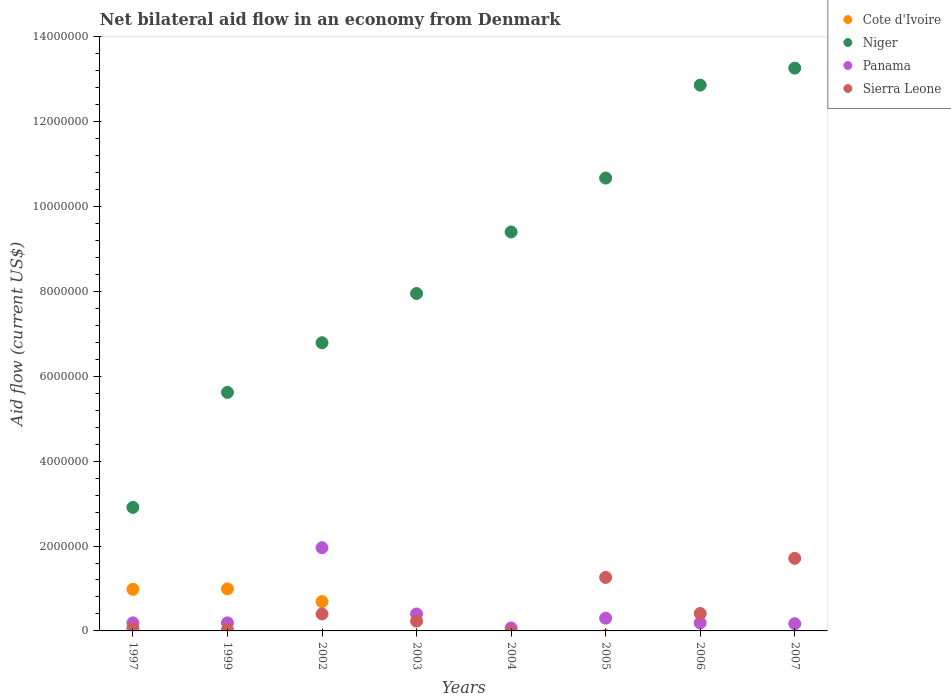How many different coloured dotlines are there?
Your response must be concise. 4. Is the number of dotlines equal to the number of legend labels?
Ensure brevity in your answer.  No. Across all years, what is the maximum net bilateral aid flow in Niger?
Your answer should be very brief. 1.33e+07. Across all years, what is the minimum net bilateral aid flow in Niger?
Provide a short and direct response. 2.91e+06. In which year was the net bilateral aid flow in Cote d'Ivoire maximum?
Give a very brief answer. 1999. What is the total net bilateral aid flow in Sierra Leone in the graph?
Provide a short and direct response. 4.10e+06. What is the difference between the net bilateral aid flow in Niger in 2004 and that in 2005?
Ensure brevity in your answer.  -1.27e+06. What is the difference between the net bilateral aid flow in Sierra Leone in 1999 and the net bilateral aid flow in Cote d'Ivoire in 2005?
Provide a succinct answer. 3.00e+04. What is the average net bilateral aid flow in Panama per year?
Your answer should be very brief. 4.34e+05. In the year 2006, what is the difference between the net bilateral aid flow in Panama and net bilateral aid flow in Niger?
Your answer should be compact. -1.27e+07. In how many years, is the net bilateral aid flow in Sierra Leone greater than 6800000 US$?
Keep it short and to the point. 0. Is the difference between the net bilateral aid flow in Panama in 1999 and 2005 greater than the difference between the net bilateral aid flow in Niger in 1999 and 2005?
Make the answer very short. Yes. What is the difference between the highest and the second highest net bilateral aid flow in Niger?
Offer a very short reply. 4.00e+05. What is the difference between the highest and the lowest net bilateral aid flow in Cote d'Ivoire?
Provide a short and direct response. 9.90e+05. Is it the case that in every year, the sum of the net bilateral aid flow in Cote d'Ivoire and net bilateral aid flow in Panama  is greater than the sum of net bilateral aid flow in Niger and net bilateral aid flow in Sierra Leone?
Your answer should be very brief. No. Is it the case that in every year, the sum of the net bilateral aid flow in Sierra Leone and net bilateral aid flow in Cote d'Ivoire  is greater than the net bilateral aid flow in Niger?
Keep it short and to the point. No. Are the values on the major ticks of Y-axis written in scientific E-notation?
Keep it short and to the point. No. Where does the legend appear in the graph?
Your answer should be very brief. Top right. What is the title of the graph?
Make the answer very short. Net bilateral aid flow in an economy from Denmark. Does "Serbia" appear as one of the legend labels in the graph?
Keep it short and to the point. No. What is the label or title of the X-axis?
Provide a succinct answer. Years. What is the label or title of the Y-axis?
Offer a terse response. Aid flow (current US$). What is the Aid flow (current US$) in Cote d'Ivoire in 1997?
Make the answer very short. 9.80e+05. What is the Aid flow (current US$) in Niger in 1997?
Ensure brevity in your answer.  2.91e+06. What is the Aid flow (current US$) in Panama in 1997?
Offer a terse response. 1.90e+05. What is the Aid flow (current US$) of Sierra Leone in 1997?
Keep it short and to the point. 6.00e+04. What is the Aid flow (current US$) in Cote d'Ivoire in 1999?
Offer a very short reply. 9.90e+05. What is the Aid flow (current US$) of Niger in 1999?
Offer a very short reply. 5.62e+06. What is the Aid flow (current US$) of Cote d'Ivoire in 2002?
Provide a short and direct response. 6.90e+05. What is the Aid flow (current US$) in Niger in 2002?
Offer a terse response. 6.79e+06. What is the Aid flow (current US$) of Panama in 2002?
Provide a succinct answer. 1.96e+06. What is the Aid flow (current US$) in Niger in 2003?
Give a very brief answer. 7.95e+06. What is the Aid flow (current US$) in Cote d'Ivoire in 2004?
Your response must be concise. 0. What is the Aid flow (current US$) in Niger in 2004?
Your answer should be very brief. 9.40e+06. What is the Aid flow (current US$) of Panama in 2004?
Your response must be concise. 7.00e+04. What is the Aid flow (current US$) in Cote d'Ivoire in 2005?
Ensure brevity in your answer.  0. What is the Aid flow (current US$) of Niger in 2005?
Your answer should be compact. 1.07e+07. What is the Aid flow (current US$) of Sierra Leone in 2005?
Provide a succinct answer. 1.26e+06. What is the Aid flow (current US$) in Niger in 2006?
Offer a very short reply. 1.29e+07. What is the Aid flow (current US$) of Panama in 2006?
Provide a short and direct response. 1.90e+05. What is the Aid flow (current US$) in Sierra Leone in 2006?
Your answer should be compact. 4.10e+05. What is the Aid flow (current US$) in Cote d'Ivoire in 2007?
Give a very brief answer. 0. What is the Aid flow (current US$) of Niger in 2007?
Provide a short and direct response. 1.33e+07. What is the Aid flow (current US$) in Panama in 2007?
Provide a succinct answer. 1.70e+05. What is the Aid flow (current US$) of Sierra Leone in 2007?
Give a very brief answer. 1.71e+06. Across all years, what is the maximum Aid flow (current US$) of Cote d'Ivoire?
Provide a short and direct response. 9.90e+05. Across all years, what is the maximum Aid flow (current US$) in Niger?
Your answer should be very brief. 1.33e+07. Across all years, what is the maximum Aid flow (current US$) of Panama?
Your response must be concise. 1.96e+06. Across all years, what is the maximum Aid flow (current US$) of Sierra Leone?
Your answer should be compact. 1.71e+06. Across all years, what is the minimum Aid flow (current US$) in Cote d'Ivoire?
Ensure brevity in your answer.  0. Across all years, what is the minimum Aid flow (current US$) of Niger?
Offer a very short reply. 2.91e+06. Across all years, what is the minimum Aid flow (current US$) of Panama?
Your response must be concise. 7.00e+04. What is the total Aid flow (current US$) of Cote d'Ivoire in the graph?
Your response must be concise. 2.66e+06. What is the total Aid flow (current US$) in Niger in the graph?
Make the answer very short. 6.95e+07. What is the total Aid flow (current US$) of Panama in the graph?
Your answer should be very brief. 3.47e+06. What is the total Aid flow (current US$) in Sierra Leone in the graph?
Keep it short and to the point. 4.10e+06. What is the difference between the Aid flow (current US$) in Cote d'Ivoire in 1997 and that in 1999?
Offer a terse response. -10000. What is the difference between the Aid flow (current US$) in Niger in 1997 and that in 1999?
Ensure brevity in your answer.  -2.71e+06. What is the difference between the Aid flow (current US$) of Panama in 1997 and that in 1999?
Your answer should be compact. 0. What is the difference between the Aid flow (current US$) of Cote d'Ivoire in 1997 and that in 2002?
Make the answer very short. 2.90e+05. What is the difference between the Aid flow (current US$) in Niger in 1997 and that in 2002?
Your response must be concise. -3.88e+06. What is the difference between the Aid flow (current US$) in Panama in 1997 and that in 2002?
Provide a succinct answer. -1.77e+06. What is the difference between the Aid flow (current US$) in Sierra Leone in 1997 and that in 2002?
Your answer should be compact. -3.40e+05. What is the difference between the Aid flow (current US$) in Niger in 1997 and that in 2003?
Your answer should be compact. -5.04e+06. What is the difference between the Aid flow (current US$) in Panama in 1997 and that in 2003?
Offer a terse response. -2.10e+05. What is the difference between the Aid flow (current US$) of Niger in 1997 and that in 2004?
Keep it short and to the point. -6.49e+06. What is the difference between the Aid flow (current US$) in Panama in 1997 and that in 2004?
Your answer should be very brief. 1.20e+05. What is the difference between the Aid flow (current US$) of Niger in 1997 and that in 2005?
Offer a very short reply. -7.76e+06. What is the difference between the Aid flow (current US$) of Panama in 1997 and that in 2005?
Keep it short and to the point. -1.10e+05. What is the difference between the Aid flow (current US$) in Sierra Leone in 1997 and that in 2005?
Your answer should be compact. -1.20e+06. What is the difference between the Aid flow (current US$) in Niger in 1997 and that in 2006?
Keep it short and to the point. -9.95e+06. What is the difference between the Aid flow (current US$) of Sierra Leone in 1997 and that in 2006?
Offer a terse response. -3.50e+05. What is the difference between the Aid flow (current US$) in Niger in 1997 and that in 2007?
Keep it short and to the point. -1.04e+07. What is the difference between the Aid flow (current US$) in Panama in 1997 and that in 2007?
Provide a short and direct response. 2.00e+04. What is the difference between the Aid flow (current US$) of Sierra Leone in 1997 and that in 2007?
Your answer should be compact. -1.65e+06. What is the difference between the Aid flow (current US$) in Cote d'Ivoire in 1999 and that in 2002?
Your response must be concise. 3.00e+05. What is the difference between the Aid flow (current US$) in Niger in 1999 and that in 2002?
Give a very brief answer. -1.17e+06. What is the difference between the Aid flow (current US$) in Panama in 1999 and that in 2002?
Your answer should be very brief. -1.77e+06. What is the difference between the Aid flow (current US$) in Sierra Leone in 1999 and that in 2002?
Your answer should be very brief. -3.70e+05. What is the difference between the Aid flow (current US$) of Niger in 1999 and that in 2003?
Offer a very short reply. -2.33e+06. What is the difference between the Aid flow (current US$) in Sierra Leone in 1999 and that in 2003?
Your response must be concise. -2.00e+05. What is the difference between the Aid flow (current US$) of Niger in 1999 and that in 2004?
Your answer should be very brief. -3.78e+06. What is the difference between the Aid flow (current US$) of Niger in 1999 and that in 2005?
Your response must be concise. -5.05e+06. What is the difference between the Aid flow (current US$) of Panama in 1999 and that in 2005?
Make the answer very short. -1.10e+05. What is the difference between the Aid flow (current US$) in Sierra Leone in 1999 and that in 2005?
Offer a terse response. -1.23e+06. What is the difference between the Aid flow (current US$) of Niger in 1999 and that in 2006?
Make the answer very short. -7.24e+06. What is the difference between the Aid flow (current US$) of Panama in 1999 and that in 2006?
Provide a short and direct response. 0. What is the difference between the Aid flow (current US$) of Sierra Leone in 1999 and that in 2006?
Your answer should be compact. -3.80e+05. What is the difference between the Aid flow (current US$) in Niger in 1999 and that in 2007?
Give a very brief answer. -7.64e+06. What is the difference between the Aid flow (current US$) of Panama in 1999 and that in 2007?
Your answer should be compact. 2.00e+04. What is the difference between the Aid flow (current US$) of Sierra Leone in 1999 and that in 2007?
Your response must be concise. -1.68e+06. What is the difference between the Aid flow (current US$) in Niger in 2002 and that in 2003?
Provide a succinct answer. -1.16e+06. What is the difference between the Aid flow (current US$) of Panama in 2002 and that in 2003?
Keep it short and to the point. 1.56e+06. What is the difference between the Aid flow (current US$) in Sierra Leone in 2002 and that in 2003?
Make the answer very short. 1.70e+05. What is the difference between the Aid flow (current US$) of Niger in 2002 and that in 2004?
Offer a very short reply. -2.61e+06. What is the difference between the Aid flow (current US$) in Panama in 2002 and that in 2004?
Your answer should be compact. 1.89e+06. What is the difference between the Aid flow (current US$) in Niger in 2002 and that in 2005?
Offer a terse response. -3.88e+06. What is the difference between the Aid flow (current US$) of Panama in 2002 and that in 2005?
Offer a terse response. 1.66e+06. What is the difference between the Aid flow (current US$) of Sierra Leone in 2002 and that in 2005?
Your answer should be compact. -8.60e+05. What is the difference between the Aid flow (current US$) in Niger in 2002 and that in 2006?
Offer a terse response. -6.07e+06. What is the difference between the Aid flow (current US$) of Panama in 2002 and that in 2006?
Your response must be concise. 1.77e+06. What is the difference between the Aid flow (current US$) of Niger in 2002 and that in 2007?
Provide a succinct answer. -6.47e+06. What is the difference between the Aid flow (current US$) in Panama in 2002 and that in 2007?
Keep it short and to the point. 1.79e+06. What is the difference between the Aid flow (current US$) in Sierra Leone in 2002 and that in 2007?
Make the answer very short. -1.31e+06. What is the difference between the Aid flow (current US$) of Niger in 2003 and that in 2004?
Provide a succinct answer. -1.45e+06. What is the difference between the Aid flow (current US$) in Panama in 2003 and that in 2004?
Your answer should be compact. 3.30e+05. What is the difference between the Aid flow (current US$) in Niger in 2003 and that in 2005?
Give a very brief answer. -2.72e+06. What is the difference between the Aid flow (current US$) in Panama in 2003 and that in 2005?
Your answer should be compact. 1.00e+05. What is the difference between the Aid flow (current US$) in Sierra Leone in 2003 and that in 2005?
Your answer should be very brief. -1.03e+06. What is the difference between the Aid flow (current US$) in Niger in 2003 and that in 2006?
Your response must be concise. -4.91e+06. What is the difference between the Aid flow (current US$) in Niger in 2003 and that in 2007?
Your answer should be compact. -5.31e+06. What is the difference between the Aid flow (current US$) in Sierra Leone in 2003 and that in 2007?
Your answer should be very brief. -1.48e+06. What is the difference between the Aid flow (current US$) in Niger in 2004 and that in 2005?
Keep it short and to the point. -1.27e+06. What is the difference between the Aid flow (current US$) in Niger in 2004 and that in 2006?
Ensure brevity in your answer.  -3.46e+06. What is the difference between the Aid flow (current US$) of Panama in 2004 and that in 2006?
Your answer should be compact. -1.20e+05. What is the difference between the Aid flow (current US$) in Niger in 2004 and that in 2007?
Your answer should be very brief. -3.86e+06. What is the difference between the Aid flow (current US$) in Niger in 2005 and that in 2006?
Your answer should be compact. -2.19e+06. What is the difference between the Aid flow (current US$) of Panama in 2005 and that in 2006?
Your response must be concise. 1.10e+05. What is the difference between the Aid flow (current US$) in Sierra Leone in 2005 and that in 2006?
Make the answer very short. 8.50e+05. What is the difference between the Aid flow (current US$) of Niger in 2005 and that in 2007?
Ensure brevity in your answer.  -2.59e+06. What is the difference between the Aid flow (current US$) of Panama in 2005 and that in 2007?
Offer a terse response. 1.30e+05. What is the difference between the Aid flow (current US$) of Sierra Leone in 2005 and that in 2007?
Your response must be concise. -4.50e+05. What is the difference between the Aid flow (current US$) in Niger in 2006 and that in 2007?
Your answer should be very brief. -4.00e+05. What is the difference between the Aid flow (current US$) in Sierra Leone in 2006 and that in 2007?
Make the answer very short. -1.30e+06. What is the difference between the Aid flow (current US$) of Cote d'Ivoire in 1997 and the Aid flow (current US$) of Niger in 1999?
Your response must be concise. -4.64e+06. What is the difference between the Aid flow (current US$) of Cote d'Ivoire in 1997 and the Aid flow (current US$) of Panama in 1999?
Offer a terse response. 7.90e+05. What is the difference between the Aid flow (current US$) in Cote d'Ivoire in 1997 and the Aid flow (current US$) in Sierra Leone in 1999?
Offer a very short reply. 9.50e+05. What is the difference between the Aid flow (current US$) of Niger in 1997 and the Aid flow (current US$) of Panama in 1999?
Your answer should be compact. 2.72e+06. What is the difference between the Aid flow (current US$) of Niger in 1997 and the Aid flow (current US$) of Sierra Leone in 1999?
Ensure brevity in your answer.  2.88e+06. What is the difference between the Aid flow (current US$) of Panama in 1997 and the Aid flow (current US$) of Sierra Leone in 1999?
Make the answer very short. 1.60e+05. What is the difference between the Aid flow (current US$) in Cote d'Ivoire in 1997 and the Aid flow (current US$) in Niger in 2002?
Your answer should be compact. -5.81e+06. What is the difference between the Aid flow (current US$) in Cote d'Ivoire in 1997 and the Aid flow (current US$) in Panama in 2002?
Ensure brevity in your answer.  -9.80e+05. What is the difference between the Aid flow (current US$) in Cote d'Ivoire in 1997 and the Aid flow (current US$) in Sierra Leone in 2002?
Offer a terse response. 5.80e+05. What is the difference between the Aid flow (current US$) of Niger in 1997 and the Aid flow (current US$) of Panama in 2002?
Offer a terse response. 9.50e+05. What is the difference between the Aid flow (current US$) in Niger in 1997 and the Aid flow (current US$) in Sierra Leone in 2002?
Your answer should be very brief. 2.51e+06. What is the difference between the Aid flow (current US$) in Cote d'Ivoire in 1997 and the Aid flow (current US$) in Niger in 2003?
Give a very brief answer. -6.97e+06. What is the difference between the Aid flow (current US$) in Cote d'Ivoire in 1997 and the Aid flow (current US$) in Panama in 2003?
Offer a terse response. 5.80e+05. What is the difference between the Aid flow (current US$) of Cote d'Ivoire in 1997 and the Aid flow (current US$) of Sierra Leone in 2003?
Ensure brevity in your answer.  7.50e+05. What is the difference between the Aid flow (current US$) in Niger in 1997 and the Aid flow (current US$) in Panama in 2003?
Your response must be concise. 2.51e+06. What is the difference between the Aid flow (current US$) in Niger in 1997 and the Aid flow (current US$) in Sierra Leone in 2003?
Provide a succinct answer. 2.68e+06. What is the difference between the Aid flow (current US$) of Panama in 1997 and the Aid flow (current US$) of Sierra Leone in 2003?
Give a very brief answer. -4.00e+04. What is the difference between the Aid flow (current US$) in Cote d'Ivoire in 1997 and the Aid flow (current US$) in Niger in 2004?
Offer a very short reply. -8.42e+06. What is the difference between the Aid flow (current US$) of Cote d'Ivoire in 1997 and the Aid flow (current US$) of Panama in 2004?
Ensure brevity in your answer.  9.10e+05. What is the difference between the Aid flow (current US$) of Niger in 1997 and the Aid flow (current US$) of Panama in 2004?
Offer a terse response. 2.84e+06. What is the difference between the Aid flow (current US$) of Cote d'Ivoire in 1997 and the Aid flow (current US$) of Niger in 2005?
Offer a terse response. -9.69e+06. What is the difference between the Aid flow (current US$) of Cote d'Ivoire in 1997 and the Aid flow (current US$) of Panama in 2005?
Keep it short and to the point. 6.80e+05. What is the difference between the Aid flow (current US$) in Cote d'Ivoire in 1997 and the Aid flow (current US$) in Sierra Leone in 2005?
Offer a very short reply. -2.80e+05. What is the difference between the Aid flow (current US$) in Niger in 1997 and the Aid flow (current US$) in Panama in 2005?
Your answer should be compact. 2.61e+06. What is the difference between the Aid flow (current US$) of Niger in 1997 and the Aid flow (current US$) of Sierra Leone in 2005?
Your answer should be very brief. 1.65e+06. What is the difference between the Aid flow (current US$) of Panama in 1997 and the Aid flow (current US$) of Sierra Leone in 2005?
Ensure brevity in your answer.  -1.07e+06. What is the difference between the Aid flow (current US$) in Cote d'Ivoire in 1997 and the Aid flow (current US$) in Niger in 2006?
Provide a short and direct response. -1.19e+07. What is the difference between the Aid flow (current US$) of Cote d'Ivoire in 1997 and the Aid flow (current US$) of Panama in 2006?
Make the answer very short. 7.90e+05. What is the difference between the Aid flow (current US$) of Cote d'Ivoire in 1997 and the Aid flow (current US$) of Sierra Leone in 2006?
Give a very brief answer. 5.70e+05. What is the difference between the Aid flow (current US$) in Niger in 1997 and the Aid flow (current US$) in Panama in 2006?
Make the answer very short. 2.72e+06. What is the difference between the Aid flow (current US$) in Niger in 1997 and the Aid flow (current US$) in Sierra Leone in 2006?
Offer a terse response. 2.50e+06. What is the difference between the Aid flow (current US$) of Panama in 1997 and the Aid flow (current US$) of Sierra Leone in 2006?
Offer a terse response. -2.20e+05. What is the difference between the Aid flow (current US$) in Cote d'Ivoire in 1997 and the Aid flow (current US$) in Niger in 2007?
Keep it short and to the point. -1.23e+07. What is the difference between the Aid flow (current US$) in Cote d'Ivoire in 1997 and the Aid flow (current US$) in Panama in 2007?
Your response must be concise. 8.10e+05. What is the difference between the Aid flow (current US$) in Cote d'Ivoire in 1997 and the Aid flow (current US$) in Sierra Leone in 2007?
Make the answer very short. -7.30e+05. What is the difference between the Aid flow (current US$) of Niger in 1997 and the Aid flow (current US$) of Panama in 2007?
Your answer should be very brief. 2.74e+06. What is the difference between the Aid flow (current US$) in Niger in 1997 and the Aid flow (current US$) in Sierra Leone in 2007?
Your answer should be compact. 1.20e+06. What is the difference between the Aid flow (current US$) in Panama in 1997 and the Aid flow (current US$) in Sierra Leone in 2007?
Your answer should be compact. -1.52e+06. What is the difference between the Aid flow (current US$) of Cote d'Ivoire in 1999 and the Aid flow (current US$) of Niger in 2002?
Keep it short and to the point. -5.80e+06. What is the difference between the Aid flow (current US$) of Cote d'Ivoire in 1999 and the Aid flow (current US$) of Panama in 2002?
Keep it short and to the point. -9.70e+05. What is the difference between the Aid flow (current US$) of Cote d'Ivoire in 1999 and the Aid flow (current US$) of Sierra Leone in 2002?
Give a very brief answer. 5.90e+05. What is the difference between the Aid flow (current US$) in Niger in 1999 and the Aid flow (current US$) in Panama in 2002?
Make the answer very short. 3.66e+06. What is the difference between the Aid flow (current US$) of Niger in 1999 and the Aid flow (current US$) of Sierra Leone in 2002?
Your answer should be very brief. 5.22e+06. What is the difference between the Aid flow (current US$) in Panama in 1999 and the Aid flow (current US$) in Sierra Leone in 2002?
Your answer should be compact. -2.10e+05. What is the difference between the Aid flow (current US$) of Cote d'Ivoire in 1999 and the Aid flow (current US$) of Niger in 2003?
Your response must be concise. -6.96e+06. What is the difference between the Aid flow (current US$) of Cote d'Ivoire in 1999 and the Aid flow (current US$) of Panama in 2003?
Keep it short and to the point. 5.90e+05. What is the difference between the Aid flow (current US$) in Cote d'Ivoire in 1999 and the Aid flow (current US$) in Sierra Leone in 2003?
Your answer should be very brief. 7.60e+05. What is the difference between the Aid flow (current US$) of Niger in 1999 and the Aid flow (current US$) of Panama in 2003?
Ensure brevity in your answer.  5.22e+06. What is the difference between the Aid flow (current US$) in Niger in 1999 and the Aid flow (current US$) in Sierra Leone in 2003?
Provide a succinct answer. 5.39e+06. What is the difference between the Aid flow (current US$) of Cote d'Ivoire in 1999 and the Aid flow (current US$) of Niger in 2004?
Offer a terse response. -8.41e+06. What is the difference between the Aid flow (current US$) of Cote d'Ivoire in 1999 and the Aid flow (current US$) of Panama in 2004?
Ensure brevity in your answer.  9.20e+05. What is the difference between the Aid flow (current US$) of Niger in 1999 and the Aid flow (current US$) of Panama in 2004?
Your answer should be compact. 5.55e+06. What is the difference between the Aid flow (current US$) in Cote d'Ivoire in 1999 and the Aid flow (current US$) in Niger in 2005?
Provide a succinct answer. -9.68e+06. What is the difference between the Aid flow (current US$) in Cote d'Ivoire in 1999 and the Aid flow (current US$) in Panama in 2005?
Your answer should be very brief. 6.90e+05. What is the difference between the Aid flow (current US$) of Niger in 1999 and the Aid flow (current US$) of Panama in 2005?
Offer a terse response. 5.32e+06. What is the difference between the Aid flow (current US$) of Niger in 1999 and the Aid flow (current US$) of Sierra Leone in 2005?
Give a very brief answer. 4.36e+06. What is the difference between the Aid flow (current US$) in Panama in 1999 and the Aid flow (current US$) in Sierra Leone in 2005?
Give a very brief answer. -1.07e+06. What is the difference between the Aid flow (current US$) in Cote d'Ivoire in 1999 and the Aid flow (current US$) in Niger in 2006?
Provide a succinct answer. -1.19e+07. What is the difference between the Aid flow (current US$) of Cote d'Ivoire in 1999 and the Aid flow (current US$) of Sierra Leone in 2006?
Provide a succinct answer. 5.80e+05. What is the difference between the Aid flow (current US$) of Niger in 1999 and the Aid flow (current US$) of Panama in 2006?
Your response must be concise. 5.43e+06. What is the difference between the Aid flow (current US$) in Niger in 1999 and the Aid flow (current US$) in Sierra Leone in 2006?
Provide a short and direct response. 5.21e+06. What is the difference between the Aid flow (current US$) of Panama in 1999 and the Aid flow (current US$) of Sierra Leone in 2006?
Your answer should be very brief. -2.20e+05. What is the difference between the Aid flow (current US$) of Cote d'Ivoire in 1999 and the Aid flow (current US$) of Niger in 2007?
Your answer should be very brief. -1.23e+07. What is the difference between the Aid flow (current US$) of Cote d'Ivoire in 1999 and the Aid flow (current US$) of Panama in 2007?
Offer a terse response. 8.20e+05. What is the difference between the Aid flow (current US$) in Cote d'Ivoire in 1999 and the Aid flow (current US$) in Sierra Leone in 2007?
Offer a very short reply. -7.20e+05. What is the difference between the Aid flow (current US$) of Niger in 1999 and the Aid flow (current US$) of Panama in 2007?
Provide a short and direct response. 5.45e+06. What is the difference between the Aid flow (current US$) of Niger in 1999 and the Aid flow (current US$) of Sierra Leone in 2007?
Make the answer very short. 3.91e+06. What is the difference between the Aid flow (current US$) in Panama in 1999 and the Aid flow (current US$) in Sierra Leone in 2007?
Provide a short and direct response. -1.52e+06. What is the difference between the Aid flow (current US$) in Cote d'Ivoire in 2002 and the Aid flow (current US$) in Niger in 2003?
Your answer should be compact. -7.26e+06. What is the difference between the Aid flow (current US$) of Cote d'Ivoire in 2002 and the Aid flow (current US$) of Panama in 2003?
Your answer should be very brief. 2.90e+05. What is the difference between the Aid flow (current US$) in Cote d'Ivoire in 2002 and the Aid flow (current US$) in Sierra Leone in 2003?
Provide a succinct answer. 4.60e+05. What is the difference between the Aid flow (current US$) of Niger in 2002 and the Aid flow (current US$) of Panama in 2003?
Give a very brief answer. 6.39e+06. What is the difference between the Aid flow (current US$) of Niger in 2002 and the Aid flow (current US$) of Sierra Leone in 2003?
Your response must be concise. 6.56e+06. What is the difference between the Aid flow (current US$) in Panama in 2002 and the Aid flow (current US$) in Sierra Leone in 2003?
Keep it short and to the point. 1.73e+06. What is the difference between the Aid flow (current US$) of Cote d'Ivoire in 2002 and the Aid flow (current US$) of Niger in 2004?
Make the answer very short. -8.71e+06. What is the difference between the Aid flow (current US$) of Cote d'Ivoire in 2002 and the Aid flow (current US$) of Panama in 2004?
Ensure brevity in your answer.  6.20e+05. What is the difference between the Aid flow (current US$) in Niger in 2002 and the Aid flow (current US$) in Panama in 2004?
Keep it short and to the point. 6.72e+06. What is the difference between the Aid flow (current US$) in Cote d'Ivoire in 2002 and the Aid flow (current US$) in Niger in 2005?
Your answer should be very brief. -9.98e+06. What is the difference between the Aid flow (current US$) in Cote d'Ivoire in 2002 and the Aid flow (current US$) in Sierra Leone in 2005?
Ensure brevity in your answer.  -5.70e+05. What is the difference between the Aid flow (current US$) of Niger in 2002 and the Aid flow (current US$) of Panama in 2005?
Keep it short and to the point. 6.49e+06. What is the difference between the Aid flow (current US$) of Niger in 2002 and the Aid flow (current US$) of Sierra Leone in 2005?
Give a very brief answer. 5.53e+06. What is the difference between the Aid flow (current US$) in Cote d'Ivoire in 2002 and the Aid flow (current US$) in Niger in 2006?
Give a very brief answer. -1.22e+07. What is the difference between the Aid flow (current US$) of Cote d'Ivoire in 2002 and the Aid flow (current US$) of Panama in 2006?
Offer a terse response. 5.00e+05. What is the difference between the Aid flow (current US$) in Niger in 2002 and the Aid flow (current US$) in Panama in 2006?
Ensure brevity in your answer.  6.60e+06. What is the difference between the Aid flow (current US$) in Niger in 2002 and the Aid flow (current US$) in Sierra Leone in 2006?
Your answer should be compact. 6.38e+06. What is the difference between the Aid flow (current US$) of Panama in 2002 and the Aid flow (current US$) of Sierra Leone in 2006?
Give a very brief answer. 1.55e+06. What is the difference between the Aid flow (current US$) in Cote d'Ivoire in 2002 and the Aid flow (current US$) in Niger in 2007?
Your answer should be very brief. -1.26e+07. What is the difference between the Aid flow (current US$) in Cote d'Ivoire in 2002 and the Aid flow (current US$) in Panama in 2007?
Provide a succinct answer. 5.20e+05. What is the difference between the Aid flow (current US$) in Cote d'Ivoire in 2002 and the Aid flow (current US$) in Sierra Leone in 2007?
Your response must be concise. -1.02e+06. What is the difference between the Aid flow (current US$) in Niger in 2002 and the Aid flow (current US$) in Panama in 2007?
Your response must be concise. 6.62e+06. What is the difference between the Aid flow (current US$) in Niger in 2002 and the Aid flow (current US$) in Sierra Leone in 2007?
Provide a succinct answer. 5.08e+06. What is the difference between the Aid flow (current US$) in Panama in 2002 and the Aid flow (current US$) in Sierra Leone in 2007?
Your answer should be compact. 2.50e+05. What is the difference between the Aid flow (current US$) of Niger in 2003 and the Aid flow (current US$) of Panama in 2004?
Give a very brief answer. 7.88e+06. What is the difference between the Aid flow (current US$) of Niger in 2003 and the Aid flow (current US$) of Panama in 2005?
Offer a terse response. 7.65e+06. What is the difference between the Aid flow (current US$) in Niger in 2003 and the Aid flow (current US$) in Sierra Leone in 2005?
Offer a very short reply. 6.69e+06. What is the difference between the Aid flow (current US$) in Panama in 2003 and the Aid flow (current US$) in Sierra Leone in 2005?
Give a very brief answer. -8.60e+05. What is the difference between the Aid flow (current US$) in Niger in 2003 and the Aid flow (current US$) in Panama in 2006?
Give a very brief answer. 7.76e+06. What is the difference between the Aid flow (current US$) of Niger in 2003 and the Aid flow (current US$) of Sierra Leone in 2006?
Your answer should be very brief. 7.54e+06. What is the difference between the Aid flow (current US$) in Niger in 2003 and the Aid flow (current US$) in Panama in 2007?
Offer a very short reply. 7.78e+06. What is the difference between the Aid flow (current US$) of Niger in 2003 and the Aid flow (current US$) of Sierra Leone in 2007?
Your answer should be very brief. 6.24e+06. What is the difference between the Aid flow (current US$) in Panama in 2003 and the Aid flow (current US$) in Sierra Leone in 2007?
Offer a terse response. -1.31e+06. What is the difference between the Aid flow (current US$) in Niger in 2004 and the Aid flow (current US$) in Panama in 2005?
Keep it short and to the point. 9.10e+06. What is the difference between the Aid flow (current US$) of Niger in 2004 and the Aid flow (current US$) of Sierra Leone in 2005?
Your answer should be very brief. 8.14e+06. What is the difference between the Aid flow (current US$) in Panama in 2004 and the Aid flow (current US$) in Sierra Leone in 2005?
Ensure brevity in your answer.  -1.19e+06. What is the difference between the Aid flow (current US$) in Niger in 2004 and the Aid flow (current US$) in Panama in 2006?
Your answer should be very brief. 9.21e+06. What is the difference between the Aid flow (current US$) in Niger in 2004 and the Aid flow (current US$) in Sierra Leone in 2006?
Provide a succinct answer. 8.99e+06. What is the difference between the Aid flow (current US$) in Niger in 2004 and the Aid flow (current US$) in Panama in 2007?
Provide a short and direct response. 9.23e+06. What is the difference between the Aid flow (current US$) of Niger in 2004 and the Aid flow (current US$) of Sierra Leone in 2007?
Your answer should be very brief. 7.69e+06. What is the difference between the Aid flow (current US$) of Panama in 2004 and the Aid flow (current US$) of Sierra Leone in 2007?
Offer a terse response. -1.64e+06. What is the difference between the Aid flow (current US$) in Niger in 2005 and the Aid flow (current US$) in Panama in 2006?
Offer a very short reply. 1.05e+07. What is the difference between the Aid flow (current US$) of Niger in 2005 and the Aid flow (current US$) of Sierra Leone in 2006?
Offer a terse response. 1.03e+07. What is the difference between the Aid flow (current US$) of Niger in 2005 and the Aid flow (current US$) of Panama in 2007?
Make the answer very short. 1.05e+07. What is the difference between the Aid flow (current US$) in Niger in 2005 and the Aid flow (current US$) in Sierra Leone in 2007?
Ensure brevity in your answer.  8.96e+06. What is the difference between the Aid flow (current US$) in Panama in 2005 and the Aid flow (current US$) in Sierra Leone in 2007?
Ensure brevity in your answer.  -1.41e+06. What is the difference between the Aid flow (current US$) of Niger in 2006 and the Aid flow (current US$) of Panama in 2007?
Give a very brief answer. 1.27e+07. What is the difference between the Aid flow (current US$) in Niger in 2006 and the Aid flow (current US$) in Sierra Leone in 2007?
Your response must be concise. 1.12e+07. What is the difference between the Aid flow (current US$) in Panama in 2006 and the Aid flow (current US$) in Sierra Leone in 2007?
Make the answer very short. -1.52e+06. What is the average Aid flow (current US$) in Cote d'Ivoire per year?
Your response must be concise. 3.32e+05. What is the average Aid flow (current US$) of Niger per year?
Offer a very short reply. 8.68e+06. What is the average Aid flow (current US$) of Panama per year?
Give a very brief answer. 4.34e+05. What is the average Aid flow (current US$) in Sierra Leone per year?
Keep it short and to the point. 5.12e+05. In the year 1997, what is the difference between the Aid flow (current US$) in Cote d'Ivoire and Aid flow (current US$) in Niger?
Keep it short and to the point. -1.93e+06. In the year 1997, what is the difference between the Aid flow (current US$) in Cote d'Ivoire and Aid flow (current US$) in Panama?
Your answer should be very brief. 7.90e+05. In the year 1997, what is the difference between the Aid flow (current US$) in Cote d'Ivoire and Aid flow (current US$) in Sierra Leone?
Your response must be concise. 9.20e+05. In the year 1997, what is the difference between the Aid flow (current US$) of Niger and Aid flow (current US$) of Panama?
Your response must be concise. 2.72e+06. In the year 1997, what is the difference between the Aid flow (current US$) of Niger and Aid flow (current US$) of Sierra Leone?
Provide a short and direct response. 2.85e+06. In the year 1999, what is the difference between the Aid flow (current US$) of Cote d'Ivoire and Aid flow (current US$) of Niger?
Ensure brevity in your answer.  -4.63e+06. In the year 1999, what is the difference between the Aid flow (current US$) of Cote d'Ivoire and Aid flow (current US$) of Panama?
Your answer should be very brief. 8.00e+05. In the year 1999, what is the difference between the Aid flow (current US$) in Cote d'Ivoire and Aid flow (current US$) in Sierra Leone?
Your answer should be compact. 9.60e+05. In the year 1999, what is the difference between the Aid flow (current US$) in Niger and Aid flow (current US$) in Panama?
Provide a succinct answer. 5.43e+06. In the year 1999, what is the difference between the Aid flow (current US$) of Niger and Aid flow (current US$) of Sierra Leone?
Your answer should be very brief. 5.59e+06. In the year 2002, what is the difference between the Aid flow (current US$) of Cote d'Ivoire and Aid flow (current US$) of Niger?
Your answer should be compact. -6.10e+06. In the year 2002, what is the difference between the Aid flow (current US$) of Cote d'Ivoire and Aid flow (current US$) of Panama?
Your response must be concise. -1.27e+06. In the year 2002, what is the difference between the Aid flow (current US$) in Cote d'Ivoire and Aid flow (current US$) in Sierra Leone?
Offer a very short reply. 2.90e+05. In the year 2002, what is the difference between the Aid flow (current US$) in Niger and Aid flow (current US$) in Panama?
Give a very brief answer. 4.83e+06. In the year 2002, what is the difference between the Aid flow (current US$) of Niger and Aid flow (current US$) of Sierra Leone?
Your answer should be compact. 6.39e+06. In the year 2002, what is the difference between the Aid flow (current US$) of Panama and Aid flow (current US$) of Sierra Leone?
Provide a succinct answer. 1.56e+06. In the year 2003, what is the difference between the Aid flow (current US$) of Niger and Aid flow (current US$) of Panama?
Make the answer very short. 7.55e+06. In the year 2003, what is the difference between the Aid flow (current US$) of Niger and Aid flow (current US$) of Sierra Leone?
Make the answer very short. 7.72e+06. In the year 2004, what is the difference between the Aid flow (current US$) of Niger and Aid flow (current US$) of Panama?
Provide a succinct answer. 9.33e+06. In the year 2005, what is the difference between the Aid flow (current US$) in Niger and Aid flow (current US$) in Panama?
Provide a succinct answer. 1.04e+07. In the year 2005, what is the difference between the Aid flow (current US$) in Niger and Aid flow (current US$) in Sierra Leone?
Offer a terse response. 9.41e+06. In the year 2005, what is the difference between the Aid flow (current US$) in Panama and Aid flow (current US$) in Sierra Leone?
Ensure brevity in your answer.  -9.60e+05. In the year 2006, what is the difference between the Aid flow (current US$) of Niger and Aid flow (current US$) of Panama?
Offer a very short reply. 1.27e+07. In the year 2006, what is the difference between the Aid flow (current US$) of Niger and Aid flow (current US$) of Sierra Leone?
Your response must be concise. 1.24e+07. In the year 2006, what is the difference between the Aid flow (current US$) in Panama and Aid flow (current US$) in Sierra Leone?
Offer a very short reply. -2.20e+05. In the year 2007, what is the difference between the Aid flow (current US$) in Niger and Aid flow (current US$) in Panama?
Make the answer very short. 1.31e+07. In the year 2007, what is the difference between the Aid flow (current US$) of Niger and Aid flow (current US$) of Sierra Leone?
Provide a succinct answer. 1.16e+07. In the year 2007, what is the difference between the Aid flow (current US$) in Panama and Aid flow (current US$) in Sierra Leone?
Your response must be concise. -1.54e+06. What is the ratio of the Aid flow (current US$) in Niger in 1997 to that in 1999?
Make the answer very short. 0.52. What is the ratio of the Aid flow (current US$) in Panama in 1997 to that in 1999?
Provide a short and direct response. 1. What is the ratio of the Aid flow (current US$) of Cote d'Ivoire in 1997 to that in 2002?
Your answer should be very brief. 1.42. What is the ratio of the Aid flow (current US$) in Niger in 1997 to that in 2002?
Keep it short and to the point. 0.43. What is the ratio of the Aid flow (current US$) in Panama in 1997 to that in 2002?
Offer a terse response. 0.1. What is the ratio of the Aid flow (current US$) of Sierra Leone in 1997 to that in 2002?
Make the answer very short. 0.15. What is the ratio of the Aid flow (current US$) of Niger in 1997 to that in 2003?
Your answer should be very brief. 0.37. What is the ratio of the Aid flow (current US$) in Panama in 1997 to that in 2003?
Keep it short and to the point. 0.47. What is the ratio of the Aid flow (current US$) of Sierra Leone in 1997 to that in 2003?
Your response must be concise. 0.26. What is the ratio of the Aid flow (current US$) of Niger in 1997 to that in 2004?
Offer a very short reply. 0.31. What is the ratio of the Aid flow (current US$) in Panama in 1997 to that in 2004?
Keep it short and to the point. 2.71. What is the ratio of the Aid flow (current US$) of Niger in 1997 to that in 2005?
Ensure brevity in your answer.  0.27. What is the ratio of the Aid flow (current US$) of Panama in 1997 to that in 2005?
Ensure brevity in your answer.  0.63. What is the ratio of the Aid flow (current US$) of Sierra Leone in 1997 to that in 2005?
Provide a short and direct response. 0.05. What is the ratio of the Aid flow (current US$) in Niger in 1997 to that in 2006?
Your answer should be very brief. 0.23. What is the ratio of the Aid flow (current US$) of Sierra Leone in 1997 to that in 2006?
Make the answer very short. 0.15. What is the ratio of the Aid flow (current US$) of Niger in 1997 to that in 2007?
Offer a terse response. 0.22. What is the ratio of the Aid flow (current US$) of Panama in 1997 to that in 2007?
Your answer should be very brief. 1.12. What is the ratio of the Aid flow (current US$) in Sierra Leone in 1997 to that in 2007?
Your answer should be very brief. 0.04. What is the ratio of the Aid flow (current US$) in Cote d'Ivoire in 1999 to that in 2002?
Your answer should be very brief. 1.43. What is the ratio of the Aid flow (current US$) in Niger in 1999 to that in 2002?
Give a very brief answer. 0.83. What is the ratio of the Aid flow (current US$) in Panama in 1999 to that in 2002?
Make the answer very short. 0.1. What is the ratio of the Aid flow (current US$) of Sierra Leone in 1999 to that in 2002?
Give a very brief answer. 0.07. What is the ratio of the Aid flow (current US$) in Niger in 1999 to that in 2003?
Your answer should be very brief. 0.71. What is the ratio of the Aid flow (current US$) in Panama in 1999 to that in 2003?
Your response must be concise. 0.47. What is the ratio of the Aid flow (current US$) of Sierra Leone in 1999 to that in 2003?
Your answer should be compact. 0.13. What is the ratio of the Aid flow (current US$) in Niger in 1999 to that in 2004?
Provide a succinct answer. 0.6. What is the ratio of the Aid flow (current US$) of Panama in 1999 to that in 2004?
Your answer should be very brief. 2.71. What is the ratio of the Aid flow (current US$) in Niger in 1999 to that in 2005?
Keep it short and to the point. 0.53. What is the ratio of the Aid flow (current US$) in Panama in 1999 to that in 2005?
Ensure brevity in your answer.  0.63. What is the ratio of the Aid flow (current US$) in Sierra Leone in 1999 to that in 2005?
Your answer should be very brief. 0.02. What is the ratio of the Aid flow (current US$) of Niger in 1999 to that in 2006?
Keep it short and to the point. 0.44. What is the ratio of the Aid flow (current US$) of Sierra Leone in 1999 to that in 2006?
Your answer should be very brief. 0.07. What is the ratio of the Aid flow (current US$) of Niger in 1999 to that in 2007?
Provide a succinct answer. 0.42. What is the ratio of the Aid flow (current US$) of Panama in 1999 to that in 2007?
Your answer should be very brief. 1.12. What is the ratio of the Aid flow (current US$) of Sierra Leone in 1999 to that in 2007?
Provide a succinct answer. 0.02. What is the ratio of the Aid flow (current US$) of Niger in 2002 to that in 2003?
Keep it short and to the point. 0.85. What is the ratio of the Aid flow (current US$) in Panama in 2002 to that in 2003?
Your answer should be very brief. 4.9. What is the ratio of the Aid flow (current US$) of Sierra Leone in 2002 to that in 2003?
Give a very brief answer. 1.74. What is the ratio of the Aid flow (current US$) in Niger in 2002 to that in 2004?
Provide a short and direct response. 0.72. What is the ratio of the Aid flow (current US$) in Panama in 2002 to that in 2004?
Make the answer very short. 28. What is the ratio of the Aid flow (current US$) of Niger in 2002 to that in 2005?
Keep it short and to the point. 0.64. What is the ratio of the Aid flow (current US$) of Panama in 2002 to that in 2005?
Offer a terse response. 6.53. What is the ratio of the Aid flow (current US$) of Sierra Leone in 2002 to that in 2005?
Make the answer very short. 0.32. What is the ratio of the Aid flow (current US$) in Niger in 2002 to that in 2006?
Offer a very short reply. 0.53. What is the ratio of the Aid flow (current US$) of Panama in 2002 to that in 2006?
Provide a short and direct response. 10.32. What is the ratio of the Aid flow (current US$) in Sierra Leone in 2002 to that in 2006?
Offer a very short reply. 0.98. What is the ratio of the Aid flow (current US$) of Niger in 2002 to that in 2007?
Give a very brief answer. 0.51. What is the ratio of the Aid flow (current US$) of Panama in 2002 to that in 2007?
Give a very brief answer. 11.53. What is the ratio of the Aid flow (current US$) of Sierra Leone in 2002 to that in 2007?
Ensure brevity in your answer.  0.23. What is the ratio of the Aid flow (current US$) of Niger in 2003 to that in 2004?
Provide a short and direct response. 0.85. What is the ratio of the Aid flow (current US$) in Panama in 2003 to that in 2004?
Provide a short and direct response. 5.71. What is the ratio of the Aid flow (current US$) of Niger in 2003 to that in 2005?
Make the answer very short. 0.75. What is the ratio of the Aid flow (current US$) in Panama in 2003 to that in 2005?
Your answer should be compact. 1.33. What is the ratio of the Aid flow (current US$) in Sierra Leone in 2003 to that in 2005?
Your answer should be compact. 0.18. What is the ratio of the Aid flow (current US$) of Niger in 2003 to that in 2006?
Your answer should be compact. 0.62. What is the ratio of the Aid flow (current US$) of Panama in 2003 to that in 2006?
Keep it short and to the point. 2.11. What is the ratio of the Aid flow (current US$) in Sierra Leone in 2003 to that in 2006?
Ensure brevity in your answer.  0.56. What is the ratio of the Aid flow (current US$) in Niger in 2003 to that in 2007?
Offer a terse response. 0.6. What is the ratio of the Aid flow (current US$) of Panama in 2003 to that in 2007?
Offer a terse response. 2.35. What is the ratio of the Aid flow (current US$) of Sierra Leone in 2003 to that in 2007?
Provide a succinct answer. 0.13. What is the ratio of the Aid flow (current US$) in Niger in 2004 to that in 2005?
Provide a short and direct response. 0.88. What is the ratio of the Aid flow (current US$) of Panama in 2004 to that in 2005?
Ensure brevity in your answer.  0.23. What is the ratio of the Aid flow (current US$) of Niger in 2004 to that in 2006?
Ensure brevity in your answer.  0.73. What is the ratio of the Aid flow (current US$) in Panama in 2004 to that in 2006?
Your response must be concise. 0.37. What is the ratio of the Aid flow (current US$) in Niger in 2004 to that in 2007?
Give a very brief answer. 0.71. What is the ratio of the Aid flow (current US$) of Panama in 2004 to that in 2007?
Offer a very short reply. 0.41. What is the ratio of the Aid flow (current US$) of Niger in 2005 to that in 2006?
Your response must be concise. 0.83. What is the ratio of the Aid flow (current US$) of Panama in 2005 to that in 2006?
Offer a terse response. 1.58. What is the ratio of the Aid flow (current US$) of Sierra Leone in 2005 to that in 2006?
Offer a very short reply. 3.07. What is the ratio of the Aid flow (current US$) of Niger in 2005 to that in 2007?
Your answer should be very brief. 0.8. What is the ratio of the Aid flow (current US$) of Panama in 2005 to that in 2007?
Make the answer very short. 1.76. What is the ratio of the Aid flow (current US$) of Sierra Leone in 2005 to that in 2007?
Your answer should be compact. 0.74. What is the ratio of the Aid flow (current US$) of Niger in 2006 to that in 2007?
Provide a short and direct response. 0.97. What is the ratio of the Aid flow (current US$) of Panama in 2006 to that in 2007?
Provide a succinct answer. 1.12. What is the ratio of the Aid flow (current US$) of Sierra Leone in 2006 to that in 2007?
Provide a succinct answer. 0.24. What is the difference between the highest and the second highest Aid flow (current US$) in Niger?
Make the answer very short. 4.00e+05. What is the difference between the highest and the second highest Aid flow (current US$) in Panama?
Offer a terse response. 1.56e+06. What is the difference between the highest and the second highest Aid flow (current US$) of Sierra Leone?
Your answer should be very brief. 4.50e+05. What is the difference between the highest and the lowest Aid flow (current US$) in Cote d'Ivoire?
Your answer should be compact. 9.90e+05. What is the difference between the highest and the lowest Aid flow (current US$) in Niger?
Your answer should be very brief. 1.04e+07. What is the difference between the highest and the lowest Aid flow (current US$) in Panama?
Your answer should be compact. 1.89e+06. What is the difference between the highest and the lowest Aid flow (current US$) in Sierra Leone?
Provide a short and direct response. 1.71e+06. 